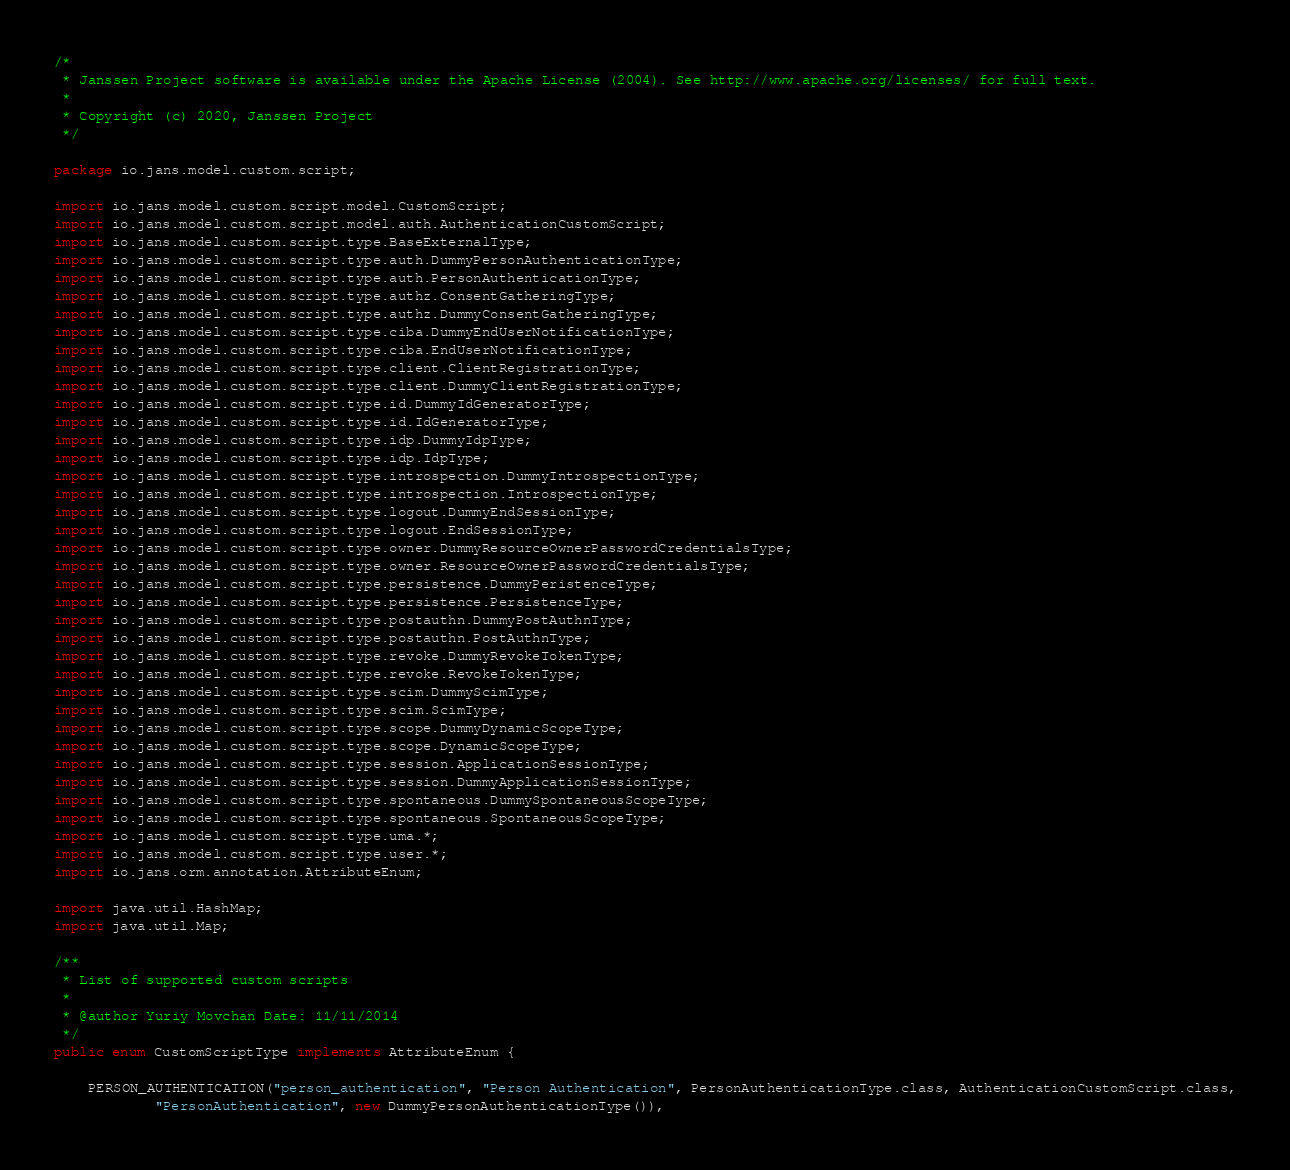<code> <loc_0><loc_0><loc_500><loc_500><_Java_>/*
 * Janssen Project software is available under the Apache License (2004). See http://www.apache.org/licenses/ for full text.
 *
 * Copyright (c) 2020, Janssen Project
 */

package io.jans.model.custom.script;

import io.jans.model.custom.script.model.CustomScript;
import io.jans.model.custom.script.model.auth.AuthenticationCustomScript;
import io.jans.model.custom.script.type.BaseExternalType;
import io.jans.model.custom.script.type.auth.DummyPersonAuthenticationType;
import io.jans.model.custom.script.type.auth.PersonAuthenticationType;
import io.jans.model.custom.script.type.authz.ConsentGatheringType;
import io.jans.model.custom.script.type.authz.DummyConsentGatheringType;
import io.jans.model.custom.script.type.ciba.DummyEndUserNotificationType;
import io.jans.model.custom.script.type.ciba.EndUserNotificationType;
import io.jans.model.custom.script.type.client.ClientRegistrationType;
import io.jans.model.custom.script.type.client.DummyClientRegistrationType;
import io.jans.model.custom.script.type.id.DummyIdGeneratorType;
import io.jans.model.custom.script.type.id.IdGeneratorType;
import io.jans.model.custom.script.type.idp.DummyIdpType;
import io.jans.model.custom.script.type.idp.IdpType;
import io.jans.model.custom.script.type.introspection.DummyIntrospectionType;
import io.jans.model.custom.script.type.introspection.IntrospectionType;
import io.jans.model.custom.script.type.logout.DummyEndSessionType;
import io.jans.model.custom.script.type.logout.EndSessionType;
import io.jans.model.custom.script.type.owner.DummyResourceOwnerPasswordCredentialsType;
import io.jans.model.custom.script.type.owner.ResourceOwnerPasswordCredentialsType;
import io.jans.model.custom.script.type.persistence.DummyPeristenceType;
import io.jans.model.custom.script.type.persistence.PersistenceType;
import io.jans.model.custom.script.type.postauthn.DummyPostAuthnType;
import io.jans.model.custom.script.type.postauthn.PostAuthnType;
import io.jans.model.custom.script.type.revoke.DummyRevokeTokenType;
import io.jans.model.custom.script.type.revoke.RevokeTokenType;
import io.jans.model.custom.script.type.scim.DummyScimType;
import io.jans.model.custom.script.type.scim.ScimType;
import io.jans.model.custom.script.type.scope.DummyDynamicScopeType;
import io.jans.model.custom.script.type.scope.DynamicScopeType;
import io.jans.model.custom.script.type.session.ApplicationSessionType;
import io.jans.model.custom.script.type.session.DummyApplicationSessionType;
import io.jans.model.custom.script.type.spontaneous.DummySpontaneousScopeType;
import io.jans.model.custom.script.type.spontaneous.SpontaneousScopeType;
import io.jans.model.custom.script.type.uma.*;
import io.jans.model.custom.script.type.user.*;
import io.jans.orm.annotation.AttributeEnum;

import java.util.HashMap;
import java.util.Map;

/**
 * List of supported custom scripts
 *
 * @author Yuriy Movchan Date: 11/11/2014
 */
public enum CustomScriptType implements AttributeEnum {

    PERSON_AUTHENTICATION("person_authentication", "Person Authentication", PersonAuthenticationType.class, AuthenticationCustomScript.class,
            "PersonAuthentication", new DummyPersonAuthenticationType()),</code> 